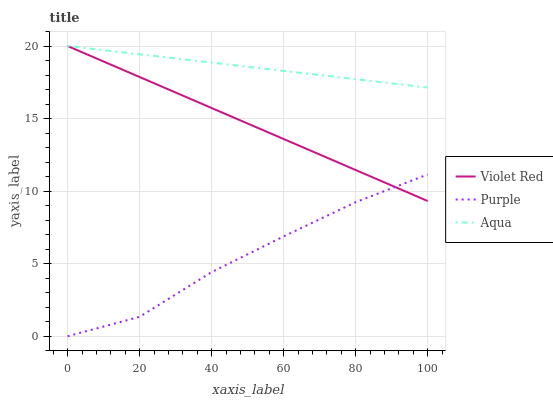Does Purple have the minimum area under the curve?
Answer yes or no. Yes. Does Aqua have the maximum area under the curve?
Answer yes or no. Yes. Does Violet Red have the minimum area under the curve?
Answer yes or no. No. Does Violet Red have the maximum area under the curve?
Answer yes or no. No. Is Violet Red the smoothest?
Answer yes or no. Yes. Is Purple the roughest?
Answer yes or no. Yes. Is Aqua the smoothest?
Answer yes or no. No. Is Aqua the roughest?
Answer yes or no. No. Does Violet Red have the lowest value?
Answer yes or no. No. Does Aqua have the highest value?
Answer yes or no. Yes. Is Purple less than Aqua?
Answer yes or no. Yes. Is Aqua greater than Purple?
Answer yes or no. Yes. Does Purple intersect Violet Red?
Answer yes or no. Yes. Is Purple less than Violet Red?
Answer yes or no. No. Is Purple greater than Violet Red?
Answer yes or no. No. Does Purple intersect Aqua?
Answer yes or no. No. 